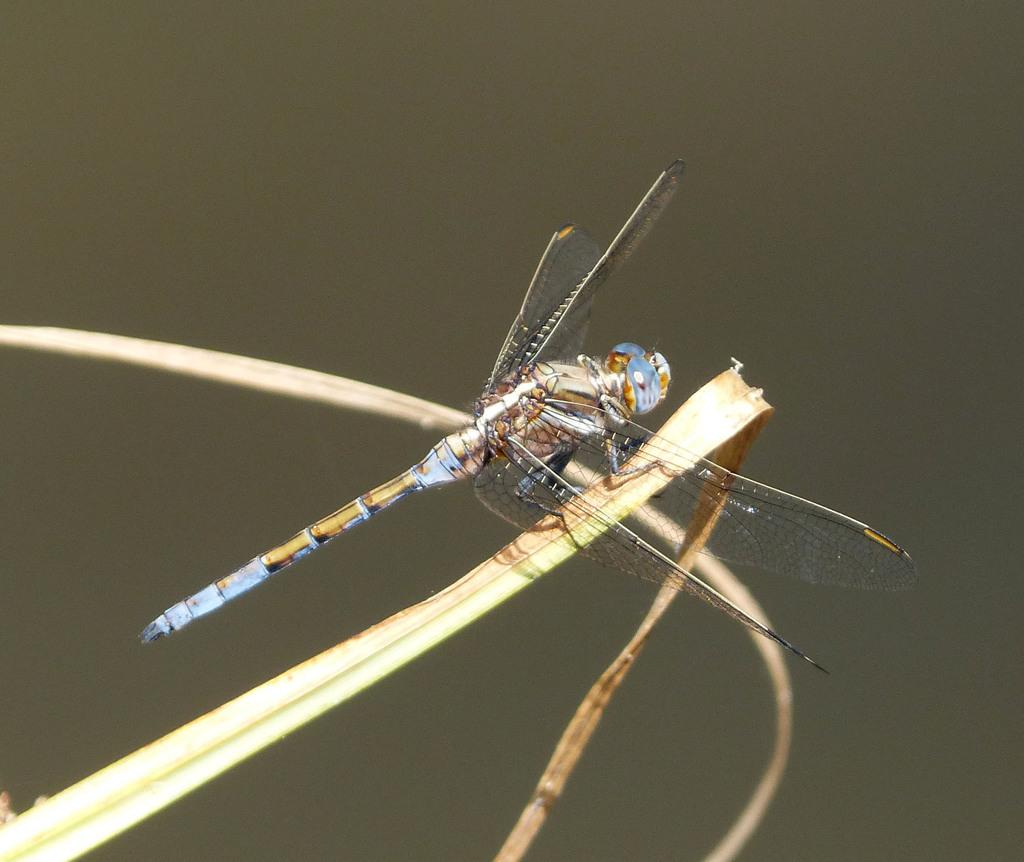What is the main subject of the image? The main subject of the image is a fly. Where is the fly located in the image? The fly is on grass in the image. Can you describe the position of the fly in the image? The fly is located in the center of the image. What type of fear does the fly exhibit in the image? There is no indication of fear in the image, as the fly is simply resting on the grass. How many ducks are present in the image? There are no ducks present in the image; it features a fly on grass. 